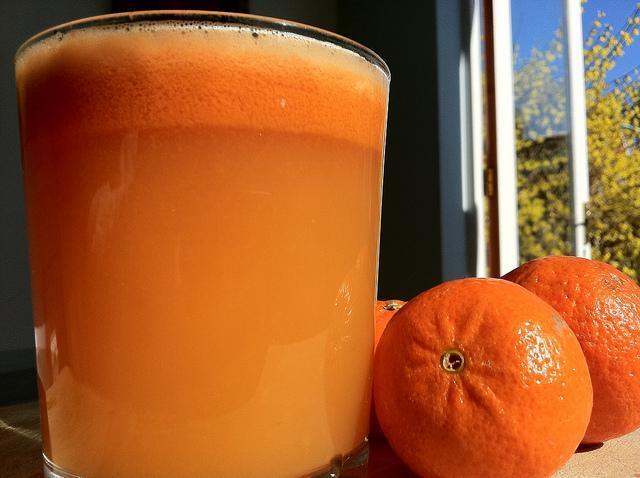How many dining tables are in the picture?
Give a very brief answer. 2. How many cups are in the picture?
Give a very brief answer. 1. How many bears are in the picture?
Give a very brief answer. 0. 